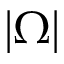Convert formula to latex. <formula><loc_0><loc_0><loc_500><loc_500>\left | \Omega \right |</formula> 